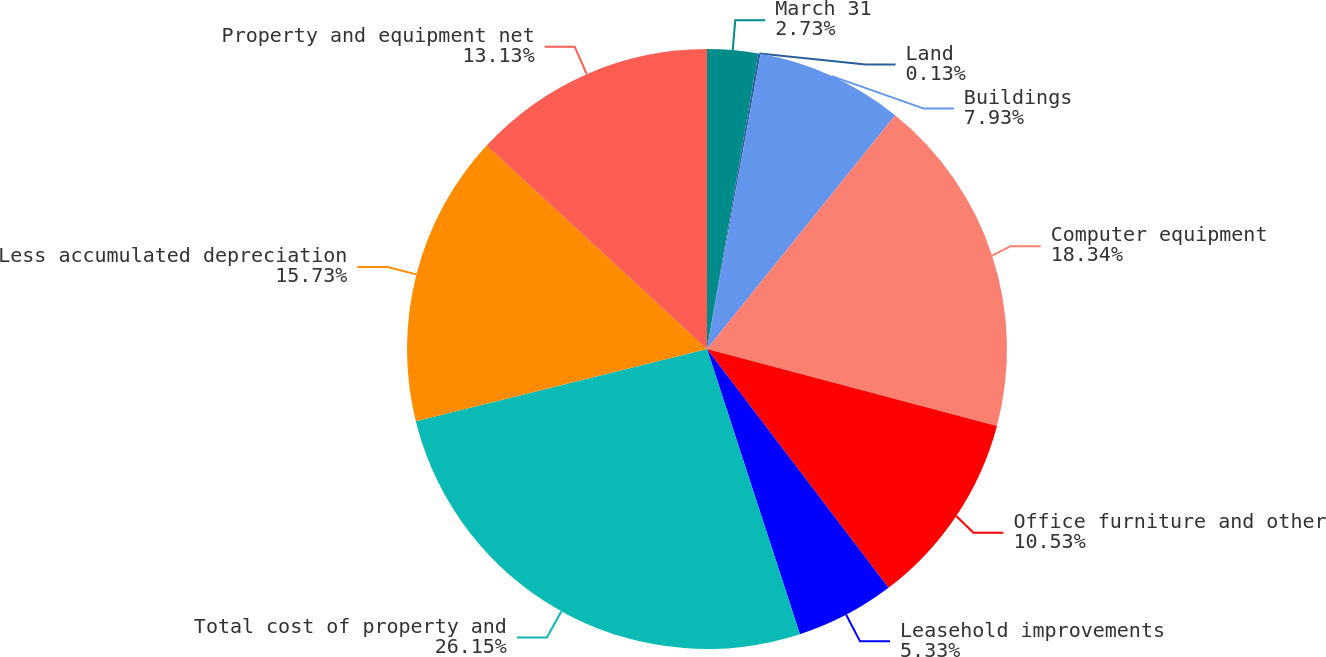<chart> <loc_0><loc_0><loc_500><loc_500><pie_chart><fcel>March 31<fcel>Land<fcel>Buildings<fcel>Computer equipment<fcel>Office furniture and other<fcel>Leasehold improvements<fcel>Total cost of property and<fcel>Less accumulated depreciation<fcel>Property and equipment net<nl><fcel>2.73%<fcel>0.13%<fcel>7.93%<fcel>18.33%<fcel>10.53%<fcel>5.33%<fcel>26.14%<fcel>15.73%<fcel>13.13%<nl></chart> 